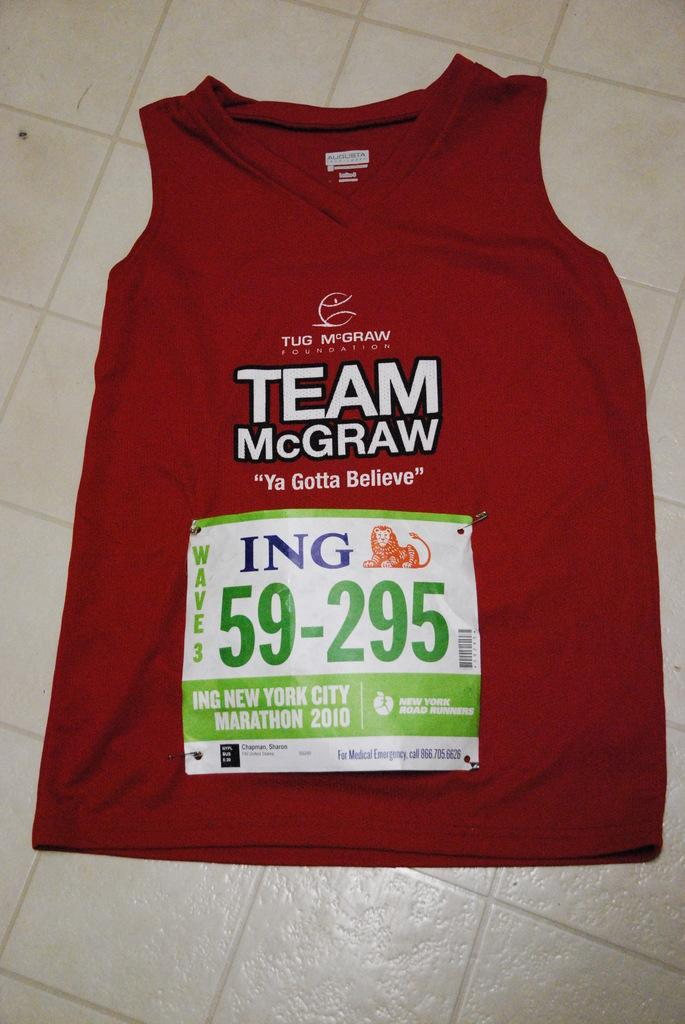What is on the floor in the image? There is a red t-shirt on the floor. What is on the red t-shirt? There is a sticker on the t-shirt. What type of fruit is hanging from the sticker on the t-shirt? There is no fruit present in the image, and the sticker is not described as having any fruit on it. 